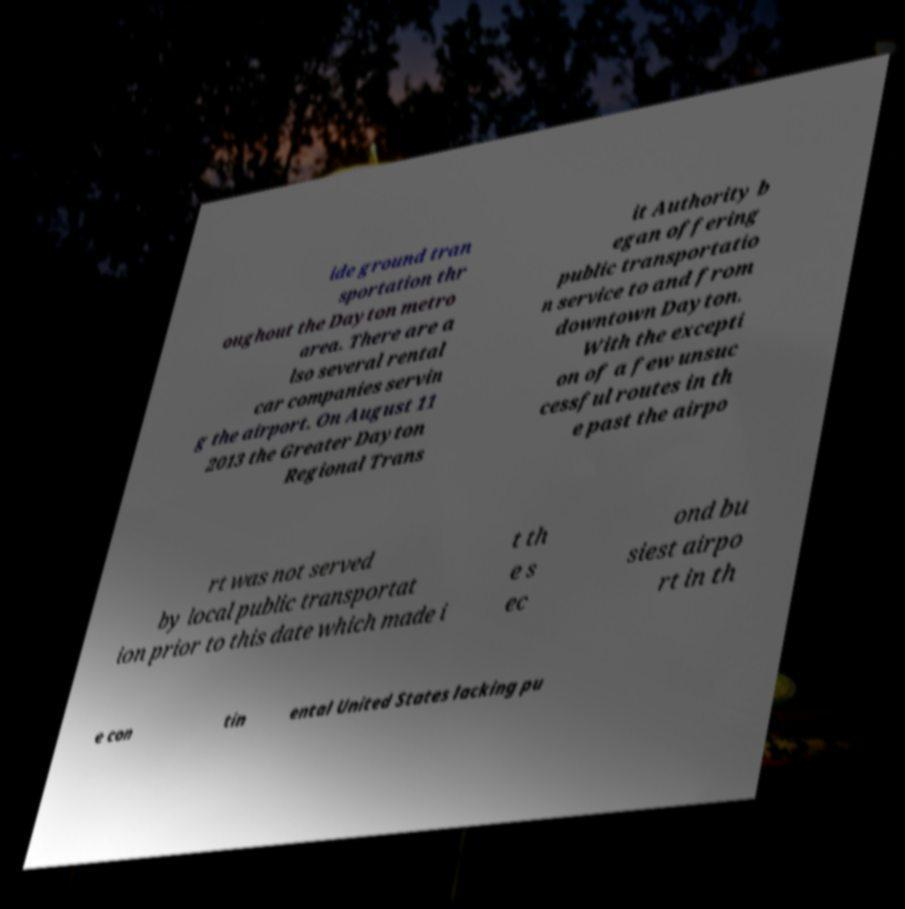What messages or text are displayed in this image? I need them in a readable, typed format. ide ground tran sportation thr oughout the Dayton metro area. There are a lso several rental car companies servin g the airport. On August 11 2013 the Greater Dayton Regional Trans it Authority b egan offering public transportatio n service to and from downtown Dayton. With the excepti on of a few unsuc cessful routes in th e past the airpo rt was not served by local public transportat ion prior to this date which made i t th e s ec ond bu siest airpo rt in th e con tin ental United States lacking pu 